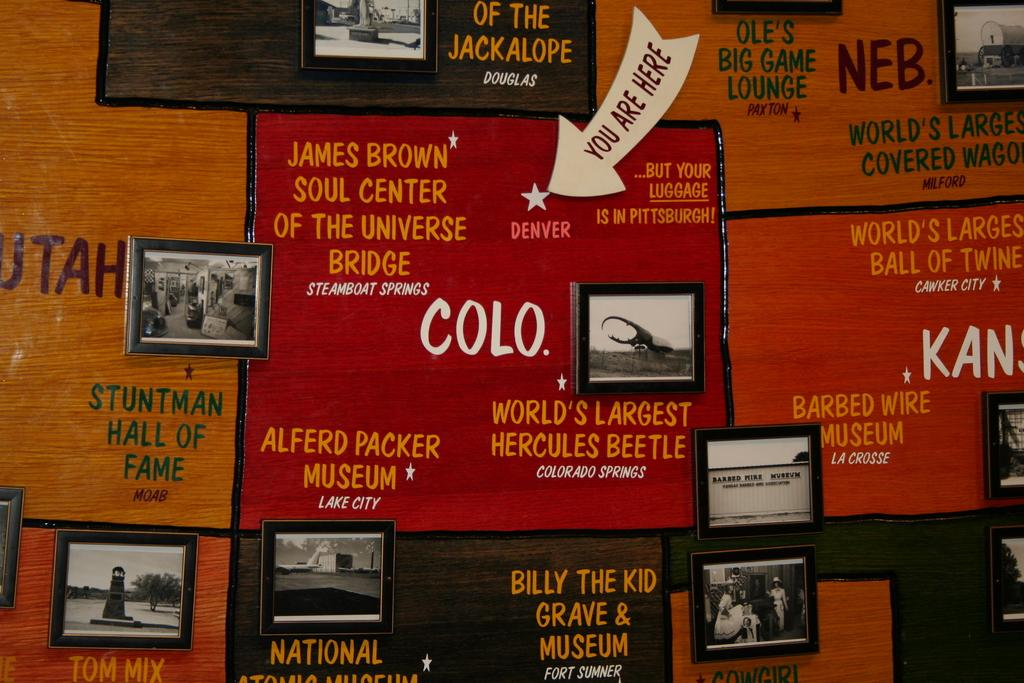<image>
Give a short and clear explanation of the subsequent image. A wooden wall with many pictures around the caption "Stuntman Hall of Fame" 